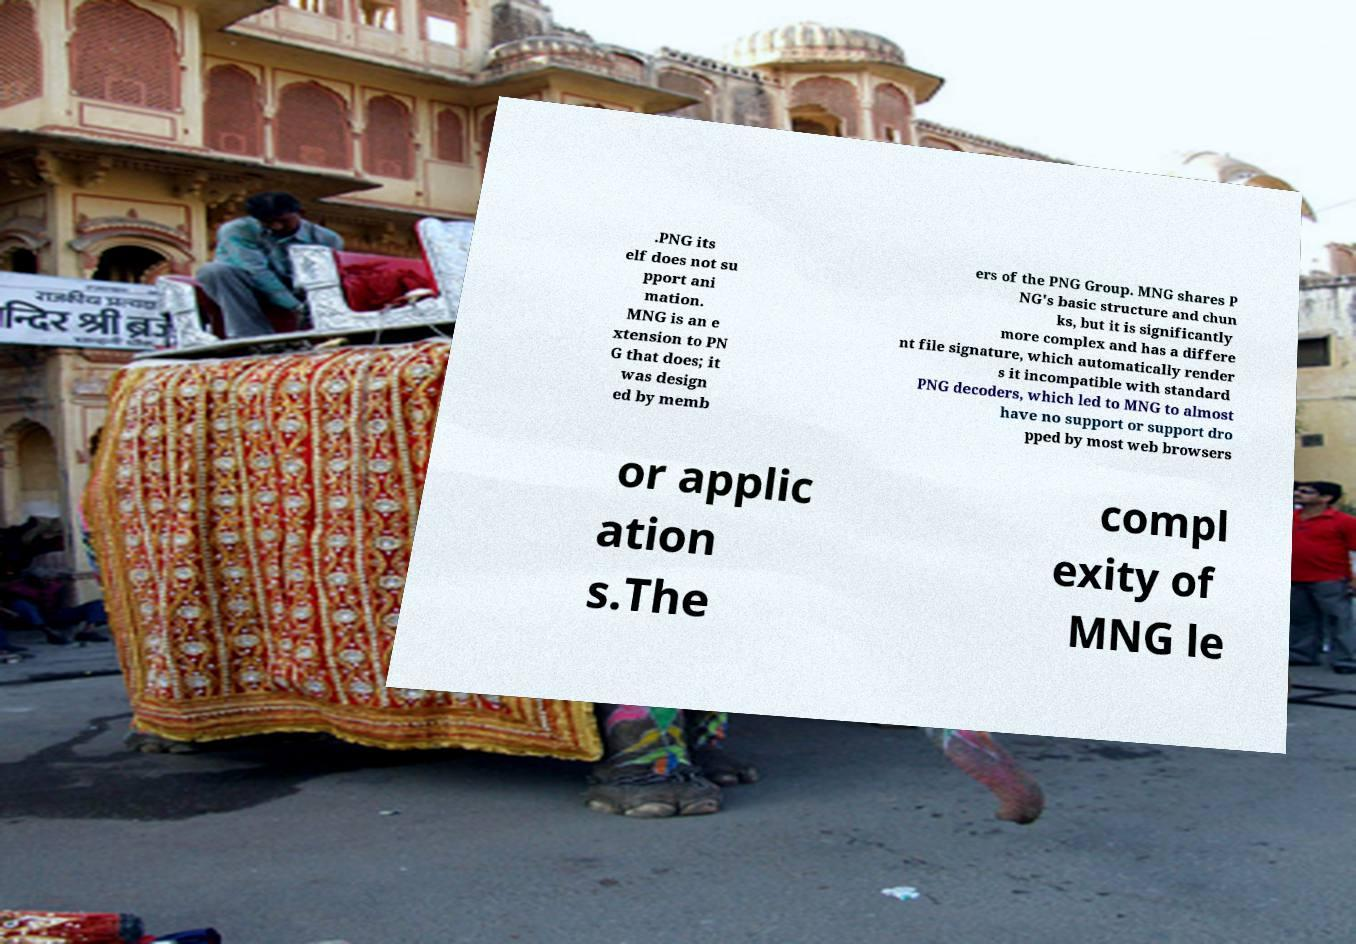Please read and relay the text visible in this image. What does it say? .PNG its elf does not su pport ani mation. MNG is an e xtension to PN G that does; it was design ed by memb ers of the PNG Group. MNG shares P NG's basic structure and chun ks, but it is significantly more complex and has a differe nt file signature, which automatically render s it incompatible with standard PNG decoders, which led to MNG to almost have no support or support dro pped by most web browsers or applic ation s.The compl exity of MNG le 